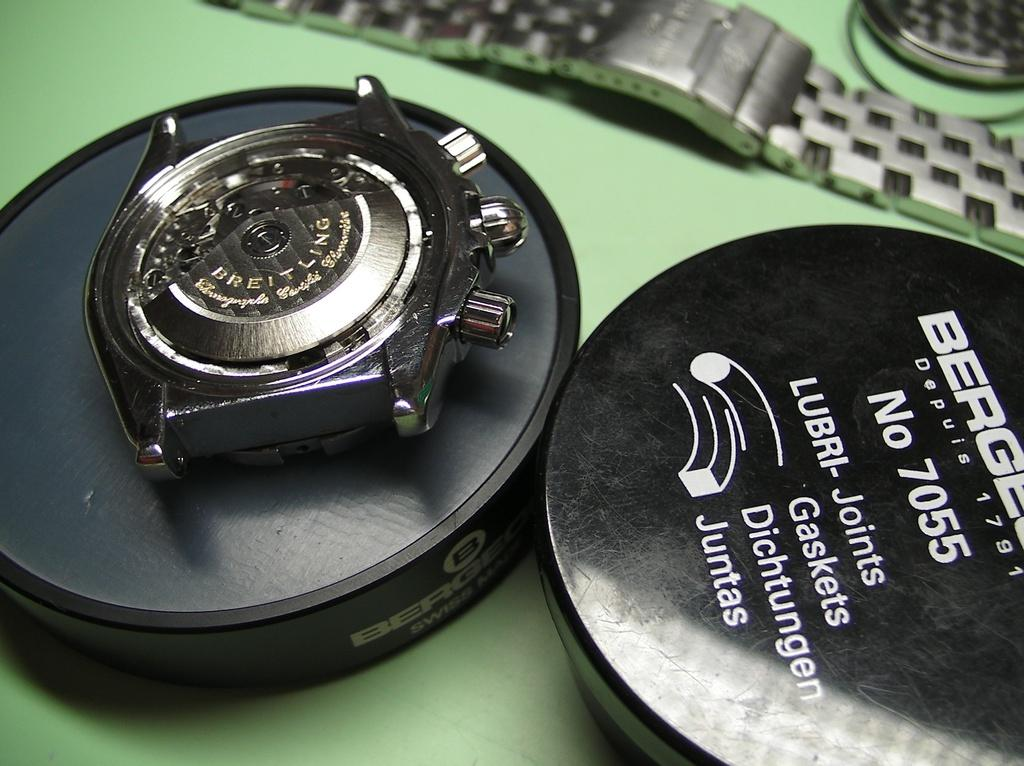<image>
Give a short and clear explanation of the subsequent image. breitling watch without band in its open round box 